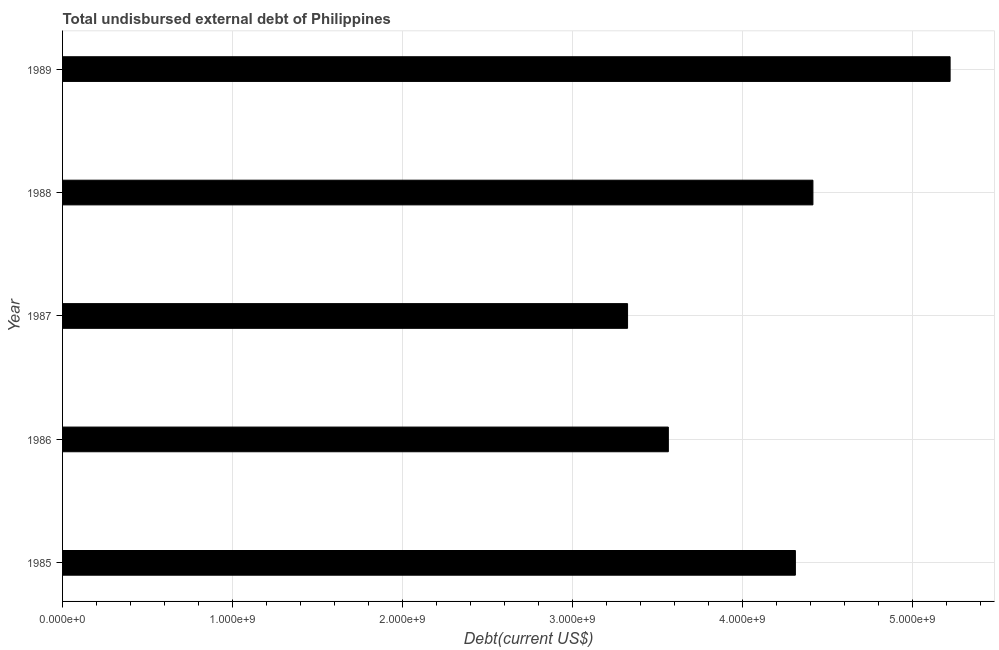Does the graph contain any zero values?
Offer a very short reply. No. Does the graph contain grids?
Give a very brief answer. Yes. What is the title of the graph?
Ensure brevity in your answer.  Total undisbursed external debt of Philippines. What is the label or title of the X-axis?
Give a very brief answer. Debt(current US$). What is the total debt in 1987?
Your response must be concise. 3.32e+09. Across all years, what is the maximum total debt?
Offer a very short reply. 5.22e+09. Across all years, what is the minimum total debt?
Offer a very short reply. 3.32e+09. In which year was the total debt minimum?
Your answer should be very brief. 1987. What is the sum of the total debt?
Provide a succinct answer. 2.08e+1. What is the difference between the total debt in 1988 and 1989?
Keep it short and to the point. -8.07e+08. What is the average total debt per year?
Give a very brief answer. 4.16e+09. What is the median total debt?
Give a very brief answer. 4.31e+09. Do a majority of the years between 1986 and 1987 (inclusive) have total debt greater than 3200000000 US$?
Keep it short and to the point. Yes. What is the ratio of the total debt in 1987 to that in 1988?
Keep it short and to the point. 0.75. What is the difference between the highest and the second highest total debt?
Your response must be concise. 8.07e+08. Is the sum of the total debt in 1987 and 1989 greater than the maximum total debt across all years?
Keep it short and to the point. Yes. What is the difference between the highest and the lowest total debt?
Your response must be concise. 1.90e+09. In how many years, is the total debt greater than the average total debt taken over all years?
Your answer should be very brief. 3. What is the difference between two consecutive major ticks on the X-axis?
Make the answer very short. 1.00e+09. Are the values on the major ticks of X-axis written in scientific E-notation?
Make the answer very short. Yes. What is the Debt(current US$) of 1985?
Offer a terse response. 4.31e+09. What is the Debt(current US$) of 1986?
Offer a terse response. 3.56e+09. What is the Debt(current US$) of 1987?
Ensure brevity in your answer.  3.32e+09. What is the Debt(current US$) of 1988?
Keep it short and to the point. 4.41e+09. What is the Debt(current US$) of 1989?
Your answer should be very brief. 5.22e+09. What is the difference between the Debt(current US$) in 1985 and 1986?
Make the answer very short. 7.47e+08. What is the difference between the Debt(current US$) in 1985 and 1987?
Your response must be concise. 9.87e+08. What is the difference between the Debt(current US$) in 1985 and 1988?
Provide a short and direct response. -1.03e+08. What is the difference between the Debt(current US$) in 1985 and 1989?
Offer a very short reply. -9.10e+08. What is the difference between the Debt(current US$) in 1986 and 1987?
Your answer should be compact. 2.40e+08. What is the difference between the Debt(current US$) in 1986 and 1988?
Keep it short and to the point. -8.50e+08. What is the difference between the Debt(current US$) in 1986 and 1989?
Give a very brief answer. -1.66e+09. What is the difference between the Debt(current US$) in 1987 and 1988?
Make the answer very short. -1.09e+09. What is the difference between the Debt(current US$) in 1987 and 1989?
Offer a very short reply. -1.90e+09. What is the difference between the Debt(current US$) in 1988 and 1989?
Give a very brief answer. -8.07e+08. What is the ratio of the Debt(current US$) in 1985 to that in 1986?
Offer a terse response. 1.21. What is the ratio of the Debt(current US$) in 1985 to that in 1987?
Offer a very short reply. 1.3. What is the ratio of the Debt(current US$) in 1985 to that in 1988?
Offer a very short reply. 0.98. What is the ratio of the Debt(current US$) in 1985 to that in 1989?
Ensure brevity in your answer.  0.83. What is the ratio of the Debt(current US$) in 1986 to that in 1987?
Your answer should be compact. 1.07. What is the ratio of the Debt(current US$) in 1986 to that in 1988?
Give a very brief answer. 0.81. What is the ratio of the Debt(current US$) in 1986 to that in 1989?
Ensure brevity in your answer.  0.68. What is the ratio of the Debt(current US$) in 1987 to that in 1988?
Offer a terse response. 0.75. What is the ratio of the Debt(current US$) in 1987 to that in 1989?
Ensure brevity in your answer.  0.64. What is the ratio of the Debt(current US$) in 1988 to that in 1989?
Your response must be concise. 0.84. 